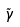Convert formula to latex. <formula><loc_0><loc_0><loc_500><loc_500>\tilde { \gamma }</formula> 